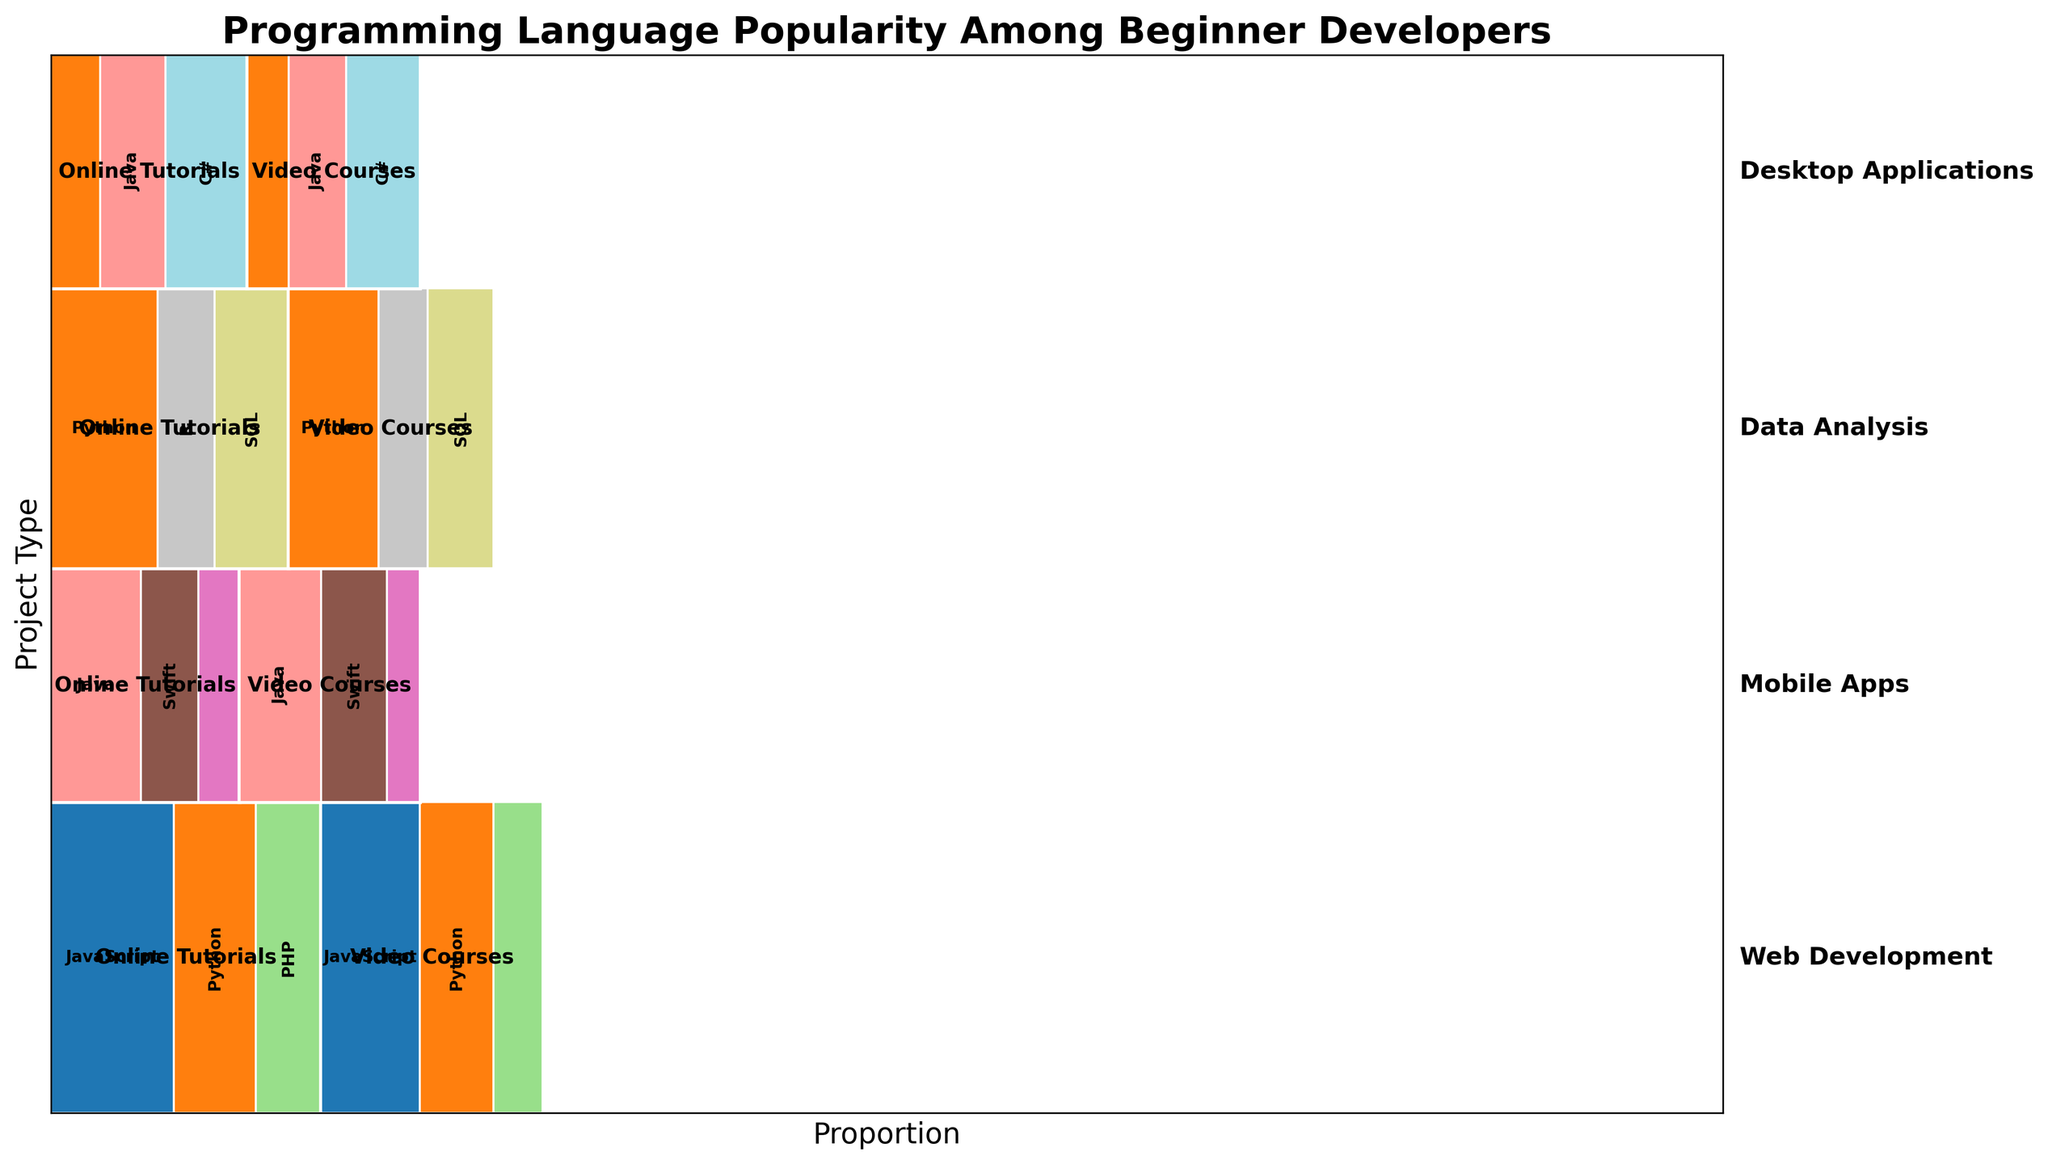What is the title of the mosaic plot? The title is displayed at the top of the plot. Titles usually provide a summary of what the figure is about. In this case, the title specifies that the plot is about programming language popularity among beginner developers.
Answer: Programming Language Popularity Among Beginner Developers Which project type has the largest proportion of programming language usage? Project types can be identified on the Y-axis of the plot. By comparing the heights of the sections representing different project types, the highest one corresponds to the project type with the largest proportion.
Answer: Web Development In Web Development, which learning resource has the higher proportion of use? Within the section for 'Web Development', compare the widths of the rectangles for each learning resource. The wider rectangle represents the resource with a higher proportion.
Answer: Online Tutorials How does the popularity of Python in Data Analysis for Online Tutorials compare to Video Courses? Identify the rectangles representing Python within the 'Data Analysis' section for both 'Online Tutorials' and 'Video Courses'. Compare their widths.
Answer: Higher in Online Tutorials What is the most popular programming language for Mobile Apps? Look at the 'Mobile Apps' section and compare the widths of the rectangles representing each programming language across all learning resources. The language with the widest combined rectangle is the most popular.
Answer: Java For Desktop Applications, how does the popularity of C# in Online Tutorials compare to Java in Video Courses? Locate the rectangles within the 'Desktop Applications' section for 'C# in Online Tutorials' and 'Java in Video Courses'. Compare their widths.
Answer: C# in Online Tutorials is more popular Which programming language has the least proportion for Video Courses in Mobile Apps? Within the 'Mobile Apps' section for 'Video Courses', identify the smallest rectangle that represents a programming language.
Answer: Kotlin Are there any programming languages that appear in all project types? Scan through each project type to identify programming languages that are represented in every project type section.
Answer: Python Within Data Analysis, how does the total proportion of SQL compare in Online Tutorials and Video Courses? Compare the sums of the widths of the rectangles representing SQL within the 'Data Analysis' section for 'Online Tutorials' and 'Video Courses'.
Answer: Higher in Online Tutorials 